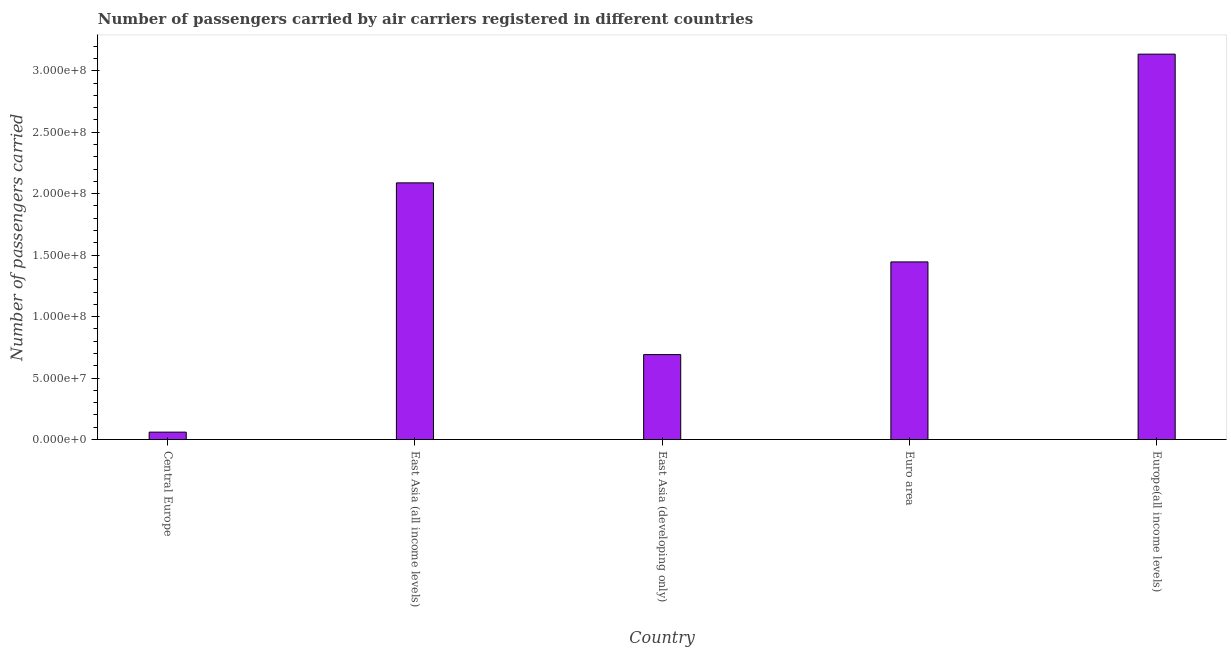What is the title of the graph?
Offer a very short reply. Number of passengers carried by air carriers registered in different countries. What is the label or title of the Y-axis?
Provide a short and direct response. Number of passengers carried. What is the number of passengers carried in Central Europe?
Offer a very short reply. 6.01e+06. Across all countries, what is the maximum number of passengers carried?
Your response must be concise. 3.14e+08. Across all countries, what is the minimum number of passengers carried?
Offer a very short reply. 6.01e+06. In which country was the number of passengers carried maximum?
Offer a terse response. Europe(all income levels). In which country was the number of passengers carried minimum?
Give a very brief answer. Central Europe. What is the sum of the number of passengers carried?
Offer a terse response. 7.42e+08. What is the difference between the number of passengers carried in East Asia (developing only) and Europe(all income levels)?
Your answer should be compact. -2.44e+08. What is the average number of passengers carried per country?
Offer a terse response. 1.48e+08. What is the median number of passengers carried?
Give a very brief answer. 1.44e+08. What is the ratio of the number of passengers carried in Central Europe to that in East Asia (developing only)?
Your answer should be compact. 0.09. What is the difference between the highest and the second highest number of passengers carried?
Give a very brief answer. 1.05e+08. Is the sum of the number of passengers carried in Euro area and Europe(all income levels) greater than the maximum number of passengers carried across all countries?
Offer a very short reply. Yes. What is the difference between the highest and the lowest number of passengers carried?
Provide a short and direct response. 3.08e+08. In how many countries, is the number of passengers carried greater than the average number of passengers carried taken over all countries?
Offer a terse response. 2. Are all the bars in the graph horizontal?
Ensure brevity in your answer.  No. What is the difference between two consecutive major ticks on the Y-axis?
Your response must be concise. 5.00e+07. Are the values on the major ticks of Y-axis written in scientific E-notation?
Offer a very short reply. Yes. What is the Number of passengers carried in Central Europe?
Provide a short and direct response. 6.01e+06. What is the Number of passengers carried of East Asia (all income levels)?
Offer a terse response. 2.09e+08. What is the Number of passengers carried of East Asia (developing only)?
Ensure brevity in your answer.  6.91e+07. What is the Number of passengers carried in Euro area?
Offer a very short reply. 1.44e+08. What is the Number of passengers carried in Europe(all income levels)?
Your response must be concise. 3.14e+08. What is the difference between the Number of passengers carried in Central Europe and East Asia (all income levels)?
Provide a succinct answer. -2.03e+08. What is the difference between the Number of passengers carried in Central Europe and East Asia (developing only)?
Make the answer very short. -6.31e+07. What is the difference between the Number of passengers carried in Central Europe and Euro area?
Provide a succinct answer. -1.38e+08. What is the difference between the Number of passengers carried in Central Europe and Europe(all income levels)?
Your response must be concise. -3.08e+08. What is the difference between the Number of passengers carried in East Asia (all income levels) and East Asia (developing only)?
Provide a succinct answer. 1.40e+08. What is the difference between the Number of passengers carried in East Asia (all income levels) and Euro area?
Your response must be concise. 6.43e+07. What is the difference between the Number of passengers carried in East Asia (all income levels) and Europe(all income levels)?
Your answer should be compact. -1.05e+08. What is the difference between the Number of passengers carried in East Asia (developing only) and Euro area?
Give a very brief answer. -7.54e+07. What is the difference between the Number of passengers carried in East Asia (developing only) and Europe(all income levels)?
Your response must be concise. -2.44e+08. What is the difference between the Number of passengers carried in Euro area and Europe(all income levels)?
Your response must be concise. -1.69e+08. What is the ratio of the Number of passengers carried in Central Europe to that in East Asia (all income levels)?
Ensure brevity in your answer.  0.03. What is the ratio of the Number of passengers carried in Central Europe to that in East Asia (developing only)?
Make the answer very short. 0.09. What is the ratio of the Number of passengers carried in Central Europe to that in Euro area?
Give a very brief answer. 0.04. What is the ratio of the Number of passengers carried in Central Europe to that in Europe(all income levels)?
Make the answer very short. 0.02. What is the ratio of the Number of passengers carried in East Asia (all income levels) to that in East Asia (developing only)?
Ensure brevity in your answer.  3.02. What is the ratio of the Number of passengers carried in East Asia (all income levels) to that in Euro area?
Your response must be concise. 1.45. What is the ratio of the Number of passengers carried in East Asia (all income levels) to that in Europe(all income levels)?
Offer a very short reply. 0.67. What is the ratio of the Number of passengers carried in East Asia (developing only) to that in Euro area?
Your answer should be very brief. 0.48. What is the ratio of the Number of passengers carried in East Asia (developing only) to that in Europe(all income levels)?
Your answer should be compact. 0.22. What is the ratio of the Number of passengers carried in Euro area to that in Europe(all income levels)?
Your answer should be very brief. 0.46. 